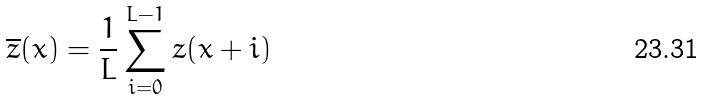<formula> <loc_0><loc_0><loc_500><loc_500>\overline { z } ( x ) = \frac { 1 } { L } \sum _ { i = 0 } ^ { L - 1 } z ( x + i )</formula> 